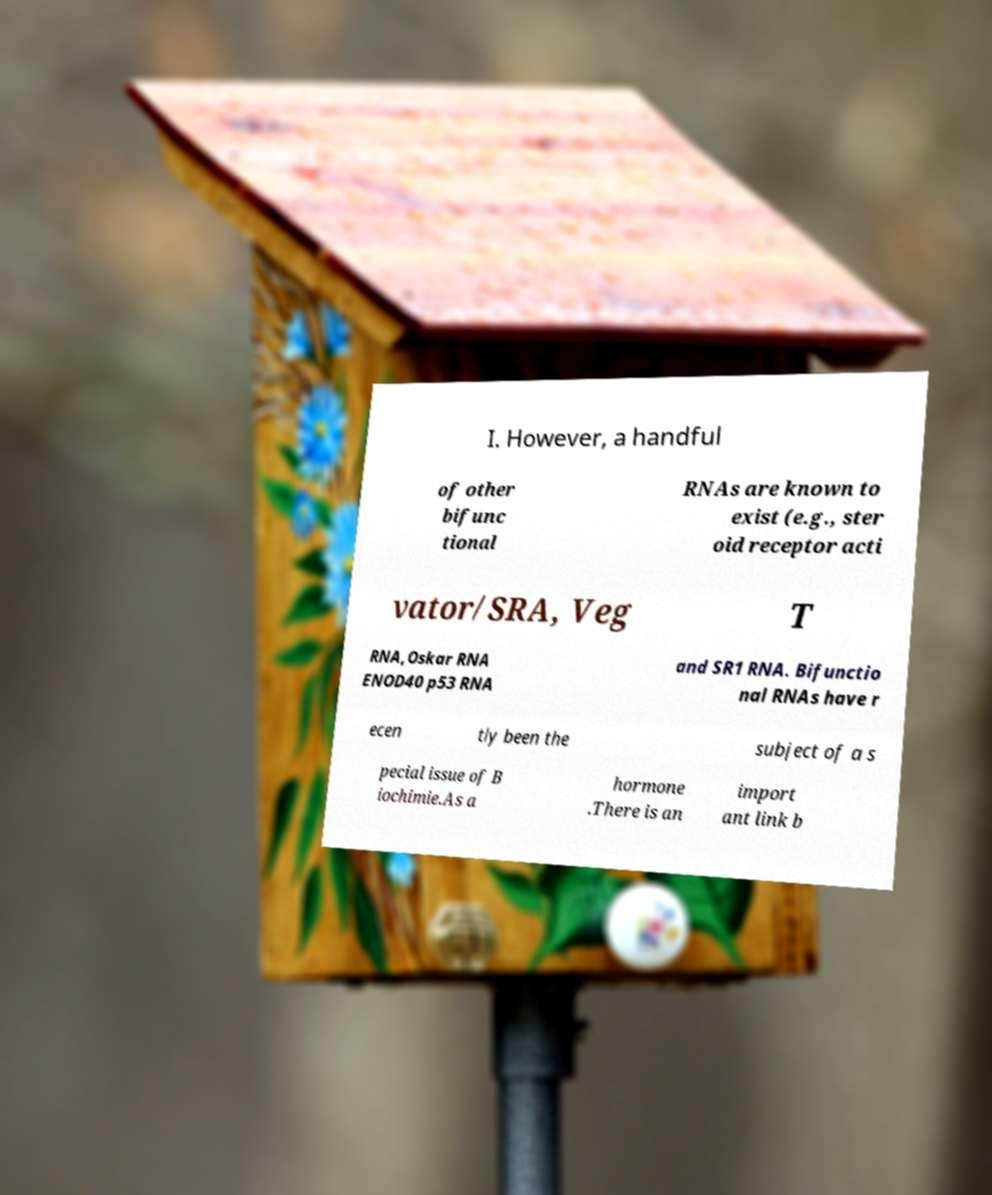There's text embedded in this image that I need extracted. Can you transcribe it verbatim? I. However, a handful of other bifunc tional RNAs are known to exist (e.g., ster oid receptor acti vator/SRA, Veg T RNA,Oskar RNA ENOD40 p53 RNA and SR1 RNA. Bifunctio nal RNAs have r ecen tly been the subject of a s pecial issue of B iochimie.As a hormone .There is an import ant link b 